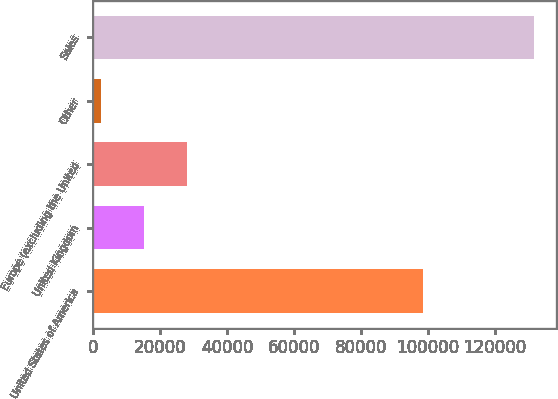Convert chart. <chart><loc_0><loc_0><loc_500><loc_500><bar_chart><fcel>United States of America<fcel>United Kingdom<fcel>Europe (excluding the United<fcel>Other<fcel>Sales<nl><fcel>98392<fcel>15182.3<fcel>28110.6<fcel>2254<fcel>131537<nl></chart> 